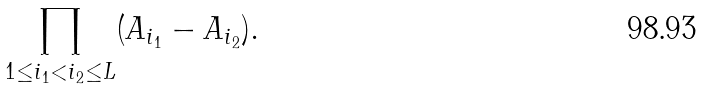Convert formula to latex. <formula><loc_0><loc_0><loc_500><loc_500>\prod _ { 1 \leq i _ { 1 } < i _ { 2 } \leq L } ( A _ { i _ { 1 } } - A _ { i _ { 2 } } ) .</formula> 